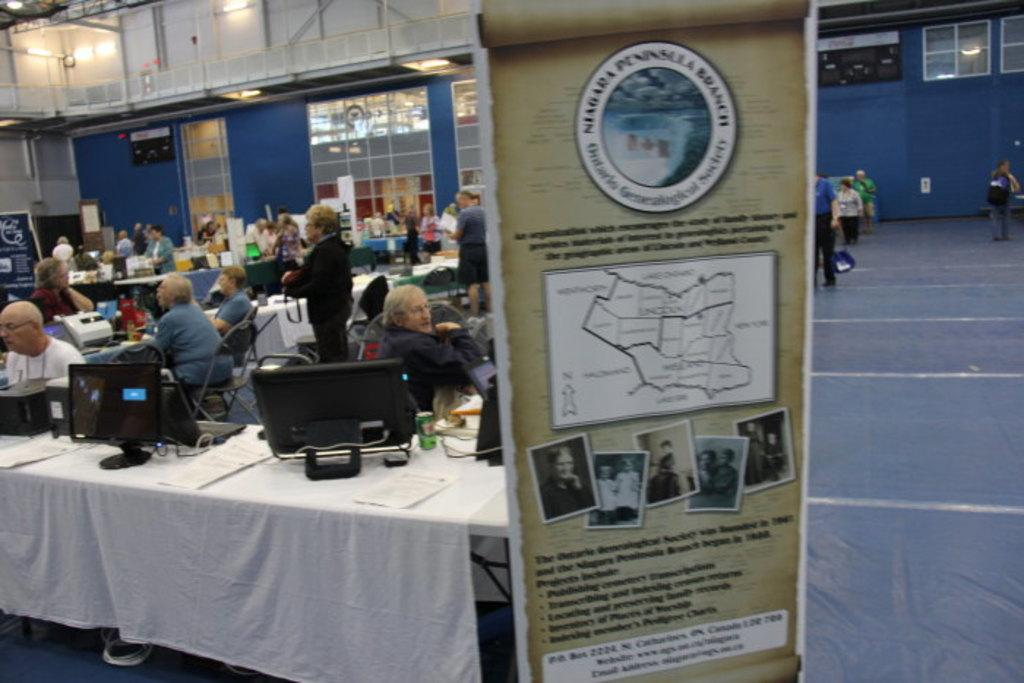<image>
Provide a brief description of the given image. A vertical sign is displayed for the Niagara Pennsylvania Branch. 